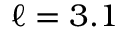Convert formula to latex. <formula><loc_0><loc_0><loc_500><loc_500>\ell = 3 . 1</formula> 